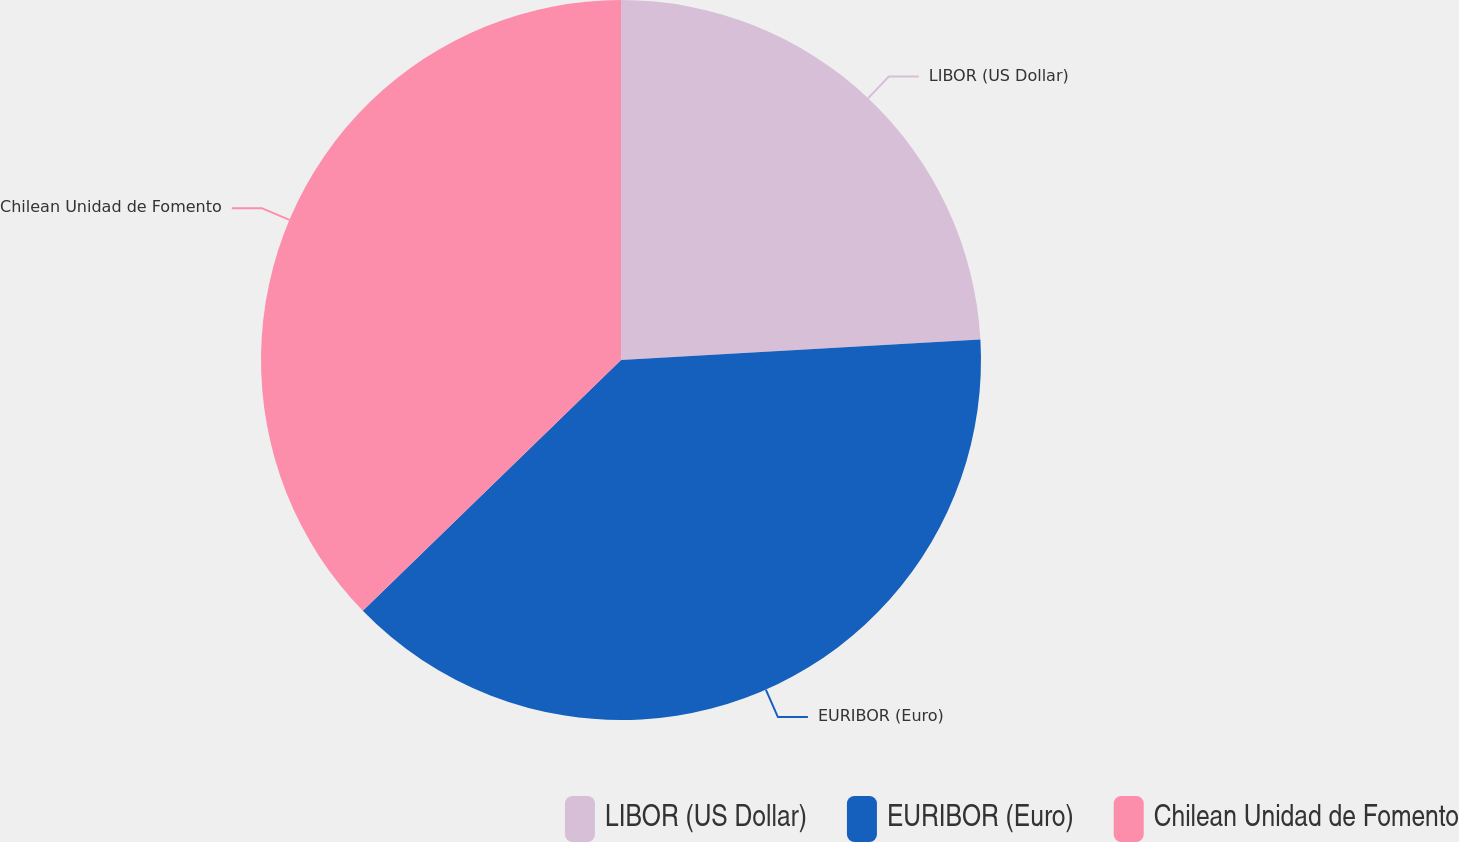<chart> <loc_0><loc_0><loc_500><loc_500><pie_chart><fcel>LIBOR (US Dollar)<fcel>EURIBOR (Euro)<fcel>Chilean Unidad de Fomento<nl><fcel>24.09%<fcel>38.64%<fcel>37.27%<nl></chart> 